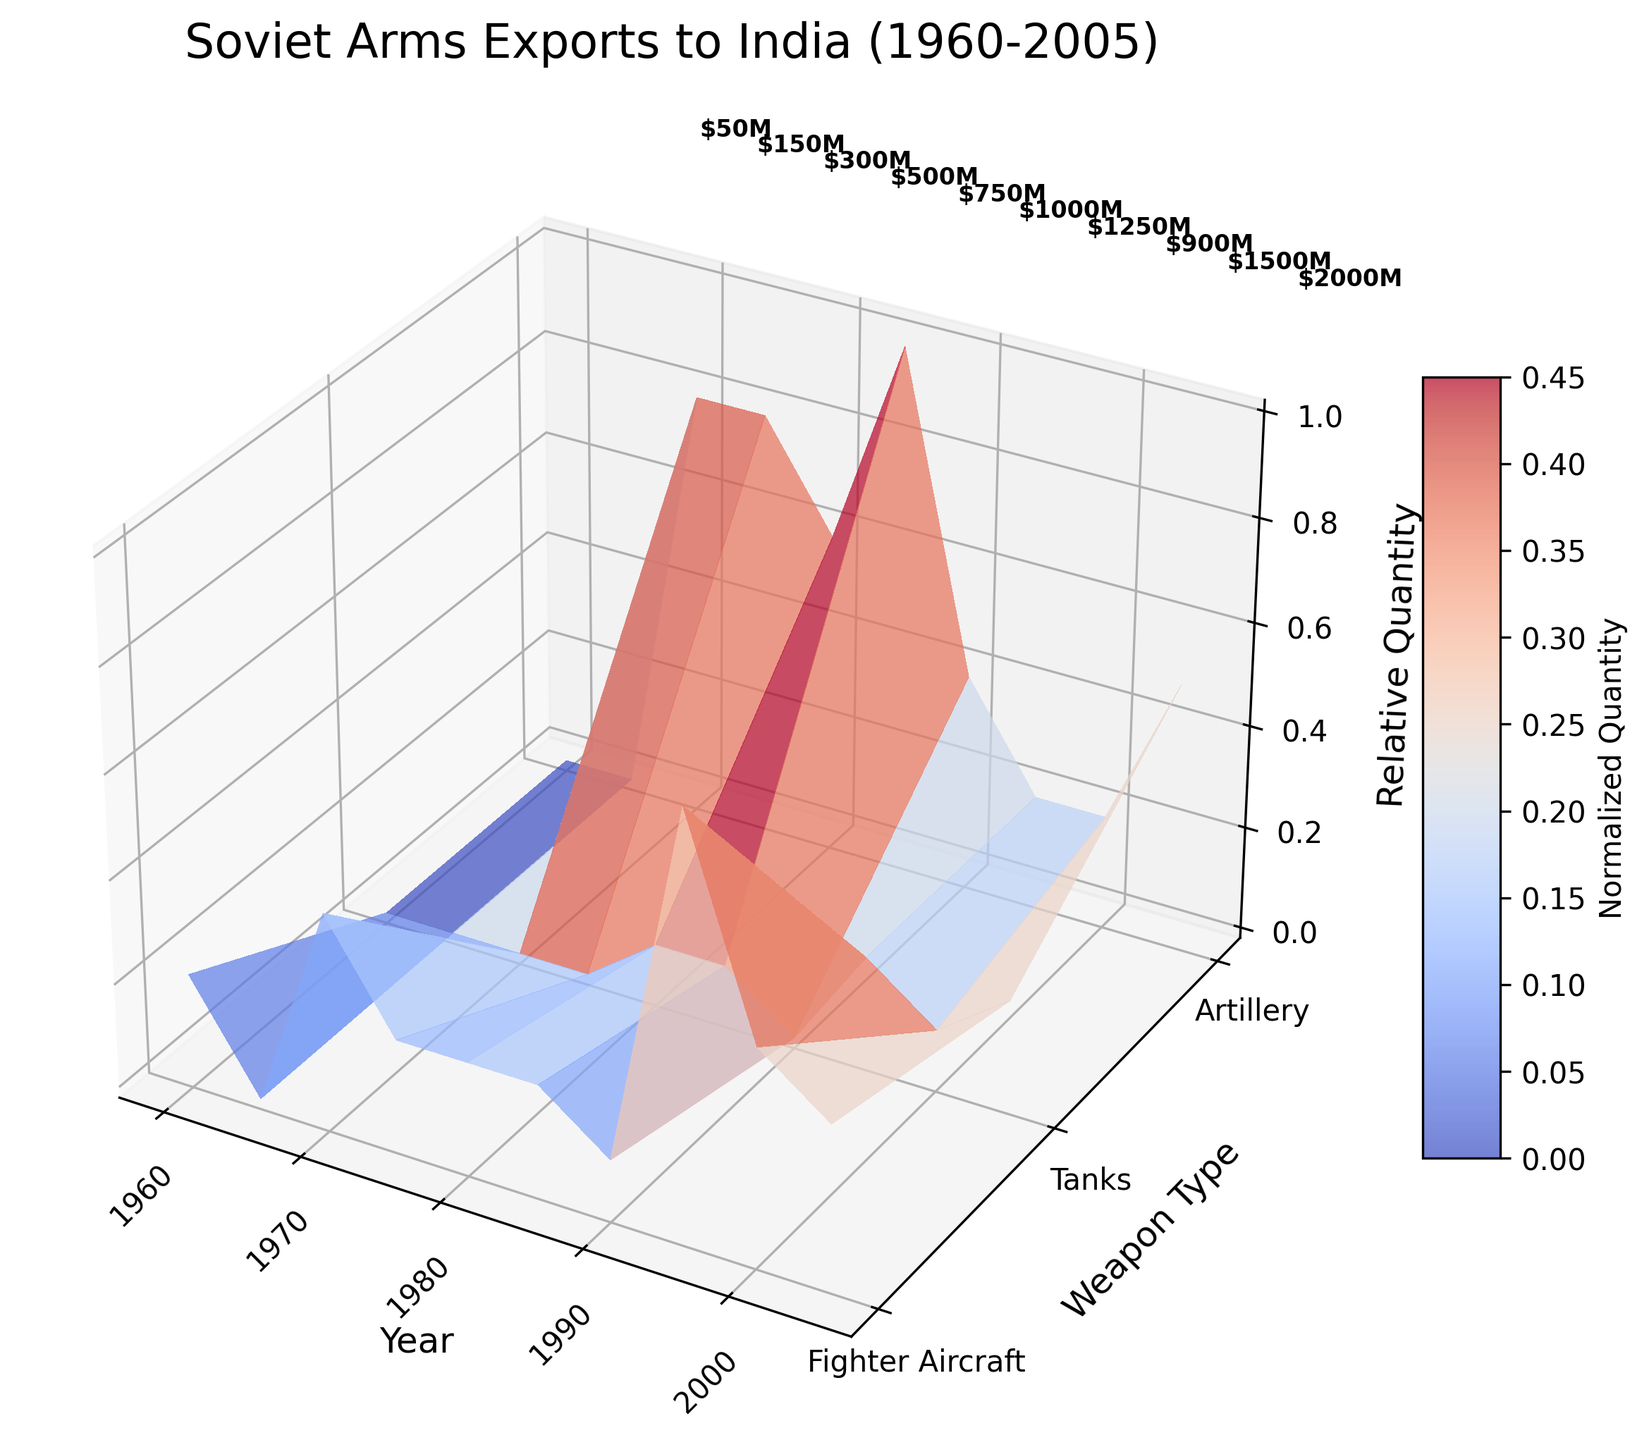What is the title of the plot? The title of the plot is displayed prominently at the top of the figure.
Answer: Soviet Arms Exports to India (1960-2005) How many different weapon types are categorized in the plot? By looking at the labels along the Y-axis, we can see that three different weapon types are categorized: Fighter Aircraft, Tanks, and Artillery.
Answer: 3 How does the surface color of the plot vary? The surface color varies from cool colors to warm colors. This indicates a transition in values where cooler colors represent lower values and warmer colors represent higher values.
Answer: From cool colors to warm colors Which year had the highest arms export value in terms of USD? The value annotations on the plot alongside the USD million values tell us that the highest export value occurred in the year 2005 with $2000 million USD.
Answer: 2005 Between which weapon types and years can we see the maximum height in the 3D surface plot? The highest point in the 3D plot can be found by observing the peaks in relative quantity along the Z-axis. It appears that between the years 2000 and 2005, for Fighter Aircraft and Tanks, the relative quantity is at its maximum.
Answer: Fighter Aircraft and Tanks between 2000 and 2005 What is the normalized quantity value for Tanks in the year 1980? The X-axis represents years, the Y-axis represents weapon types, and the Z-axis shows normalized values. By locating the normalized value at the intersection of Tanks and 1980, it appears to be relatively higher compared to other years.
Answer: Approx. 0.6 Compare the export value between 1970 and 1990. From the annotations on the plot, the export value for 1970 is $300 million and for 1990 is $1250 million. By comparison, the value in 1990 is significantly higher than in 1970.
Answer: 1990 > 1970 In which years did Fighter Aircraft reach their highest relative quantity? By following the surface plot along the Z-axis for Fighter Aircraft across all years, it seems that the highest relative quantities occurred around years 1980 and 1990.
Answer: 1980 and 1990 Which weapon type appears to have the most stability in relative quantities over the years? Observing the surface plot, Artillery seems to have a more stable surface (less variation in the Z-axis) compared to Fighter Aircraft and Tanks which have more pronounced peaks and valleys.
Answer: Artillery What's the trend in the total export value of all weapons from 1960 to 2005? By examining the height of the annotations along the overall timeline from left to right, the trend shows a generally increasing pattern in export values over the years, peaking around 2005.
Answer: Increasing trend 